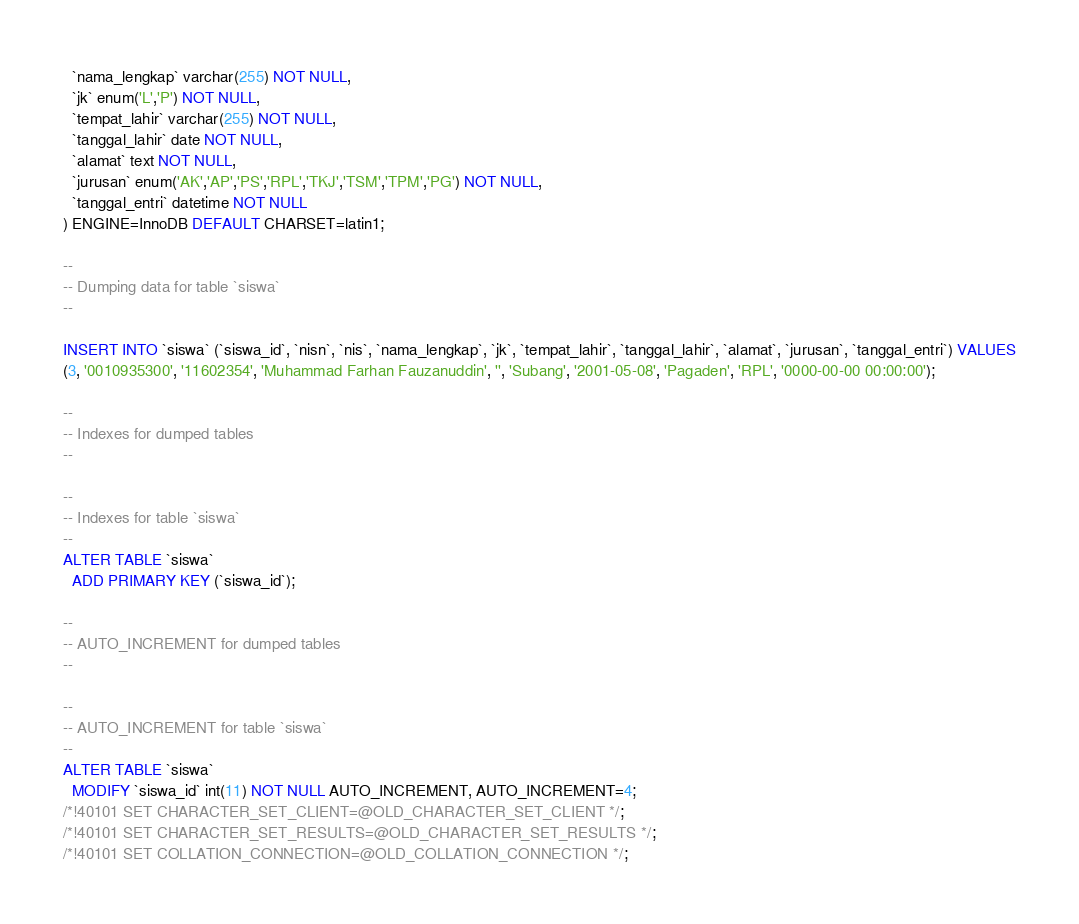Convert code to text. <code><loc_0><loc_0><loc_500><loc_500><_SQL_>  `nama_lengkap` varchar(255) NOT NULL,
  `jk` enum('L','P') NOT NULL,
  `tempat_lahir` varchar(255) NOT NULL,
  `tanggal_lahir` date NOT NULL,
  `alamat` text NOT NULL,
  `jurusan` enum('AK','AP','PS','RPL','TKJ','TSM','TPM','PG') NOT NULL,
  `tanggal_entri` datetime NOT NULL
) ENGINE=InnoDB DEFAULT CHARSET=latin1;

--
-- Dumping data for table `siswa`
--

INSERT INTO `siswa` (`siswa_id`, `nisn`, `nis`, `nama_lengkap`, `jk`, `tempat_lahir`, `tanggal_lahir`, `alamat`, `jurusan`, `tanggal_entri`) VALUES
(3, '0010935300', '11602354', 'Muhammad Farhan Fauzanuddin', '', 'Subang', '2001-05-08', 'Pagaden', 'RPL', '0000-00-00 00:00:00');

--
-- Indexes for dumped tables
--

--
-- Indexes for table `siswa`
--
ALTER TABLE `siswa`
  ADD PRIMARY KEY (`siswa_id`);

--
-- AUTO_INCREMENT for dumped tables
--

--
-- AUTO_INCREMENT for table `siswa`
--
ALTER TABLE `siswa`
  MODIFY `siswa_id` int(11) NOT NULL AUTO_INCREMENT, AUTO_INCREMENT=4;
/*!40101 SET CHARACTER_SET_CLIENT=@OLD_CHARACTER_SET_CLIENT */;
/*!40101 SET CHARACTER_SET_RESULTS=@OLD_CHARACTER_SET_RESULTS */;
/*!40101 SET COLLATION_CONNECTION=@OLD_COLLATION_CONNECTION */;
</code> 